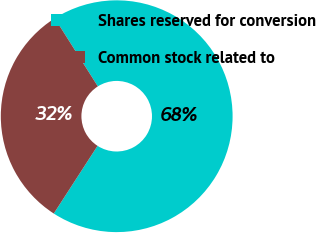Convert chart to OTSL. <chart><loc_0><loc_0><loc_500><loc_500><pie_chart><fcel>Shares reserved for conversion<fcel>Common stock related to<nl><fcel>68.11%<fcel>31.89%<nl></chart> 